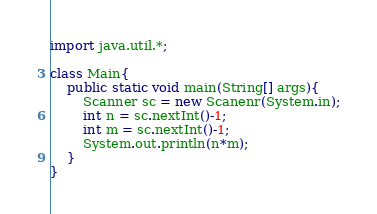Convert code to text. <code><loc_0><loc_0><loc_500><loc_500><_Java_>import java.util.*;

class Main{
	public static void main(String[] args){
    	Scanner sc = new Scanenr(System.in);
      	int n = sc.nextInt()-1;
      	int m = sc.nextInt()-1;
      	System.out.println(n*m);
    }
}

</code> 